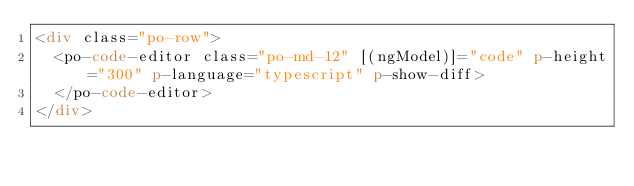Convert code to text. <code><loc_0><loc_0><loc_500><loc_500><_HTML_><div class="po-row">
  <po-code-editor class="po-md-12" [(ngModel)]="code" p-height="300" p-language="typescript" p-show-diff>
  </po-code-editor>
</div>
</code> 